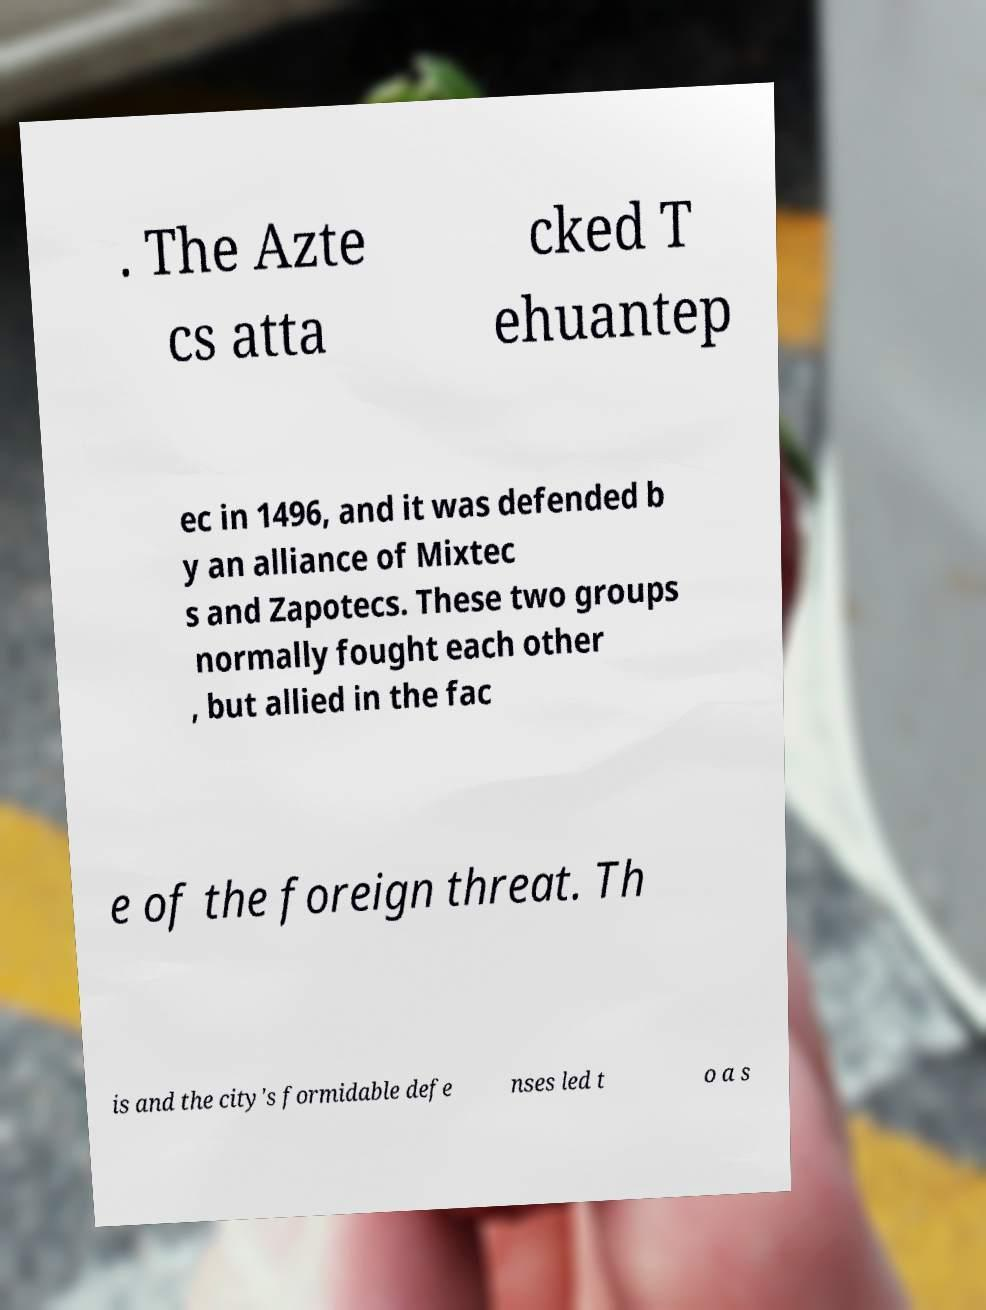Please read and relay the text visible in this image. What does it say? . The Azte cs atta cked T ehuantep ec in 1496, and it was defended b y an alliance of Mixtec s and Zapotecs. These two groups normally fought each other , but allied in the fac e of the foreign threat. Th is and the city's formidable defe nses led t o a s 